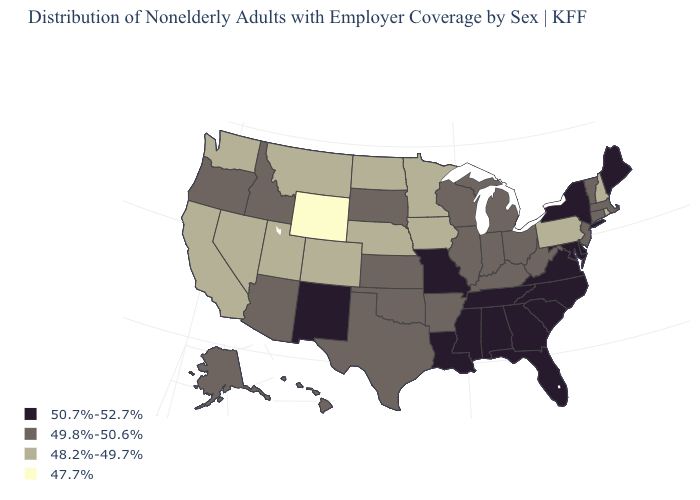Does Wyoming have the lowest value in the USA?
Quick response, please. Yes. Does Wyoming have the lowest value in the West?
Concise answer only. Yes. Which states hav the highest value in the MidWest?
Be succinct. Missouri. Does Oklahoma have a higher value than New Hampshire?
Short answer required. Yes. What is the value of Indiana?
Concise answer only. 49.8%-50.6%. What is the highest value in the USA?
Answer briefly. 50.7%-52.7%. What is the value of Missouri?
Short answer required. 50.7%-52.7%. Which states hav the highest value in the MidWest?
Be succinct. Missouri. What is the value of Idaho?
Write a very short answer. 49.8%-50.6%. Which states hav the highest value in the South?
Concise answer only. Alabama, Delaware, Florida, Georgia, Louisiana, Maryland, Mississippi, North Carolina, South Carolina, Tennessee, Virginia. Does Maryland have the highest value in the USA?
Answer briefly. Yes. What is the highest value in the MidWest ?
Short answer required. 50.7%-52.7%. Name the states that have a value in the range 50.7%-52.7%?
Write a very short answer. Alabama, Delaware, Florida, Georgia, Louisiana, Maine, Maryland, Mississippi, Missouri, New Mexico, New York, North Carolina, South Carolina, Tennessee, Virginia. Among the states that border Washington , which have the lowest value?
Give a very brief answer. Idaho, Oregon. 